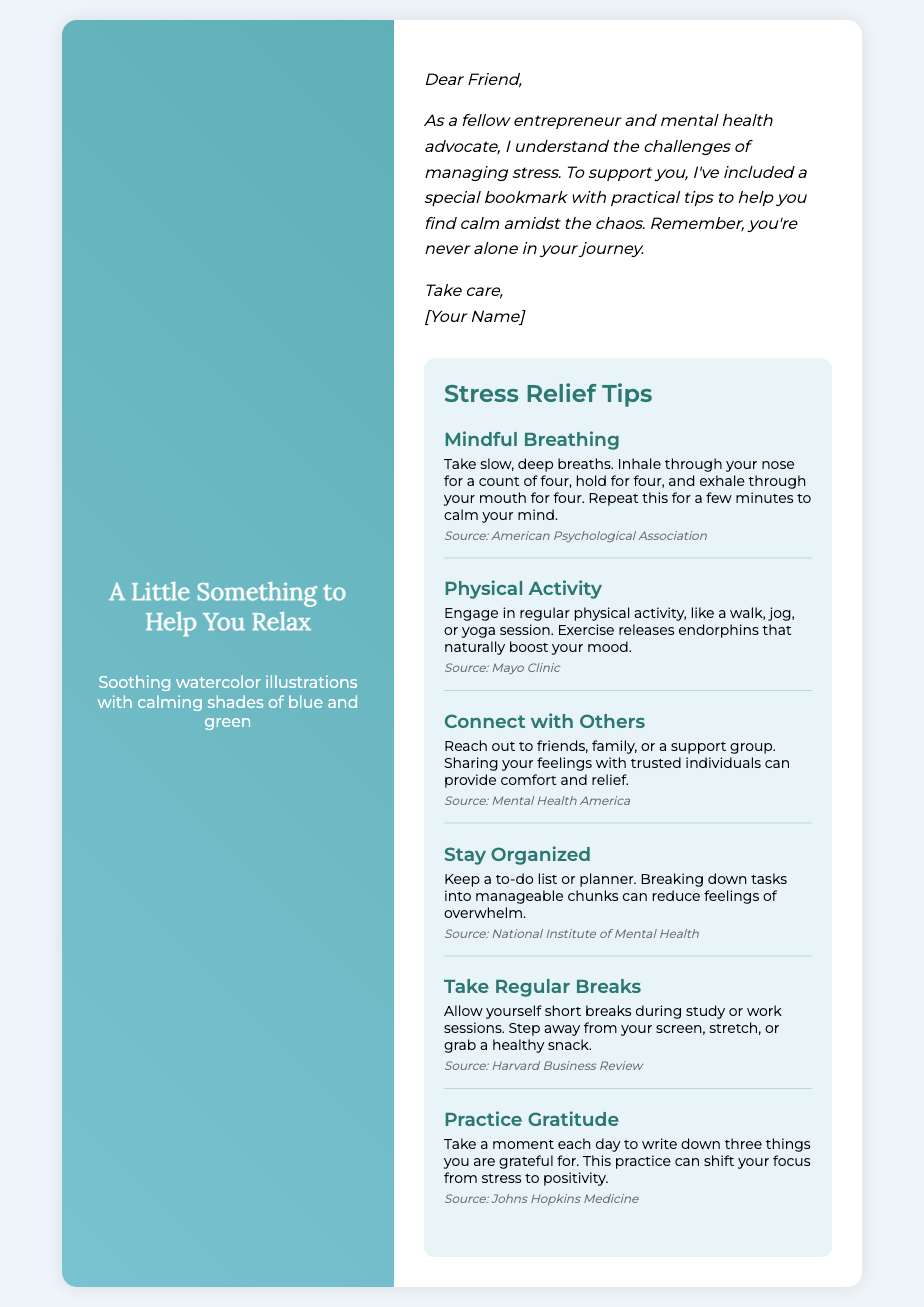What is the title of the card? The title of the card is displayed prominently in the card cover section.
Answer: A Little Something to Help You Relax How many stress relief tips are provided? The number of tips can be counted from the list in the bookmark section.
Answer: Six What is the first stress relief tip mentioned? The first tip is listed at the top of the tips section.
Answer: Mindful Breathing Which organization is cited as the source for the tip on physical activity? The source can be found at the end of the physical activity tip description.
Answer: Mayo Clinic What color palette is used for the card's design? The color scheme is described in the card cover section.
Answer: Calming shades of blue and green What does the inside message encourage the reader to do? The inside message includes supportive language aimed at the reader.
Answer: Find calm amidst the chaos What is one activity mentioned that helps relieve stress? Activities are outlined in the tips list, and one can be identified.
Answer: Yoga session Who is the card addressed to? The salutation in the inside message identifies the recipient.
Answer: Dear Friend What emotion is primarily addressed in the card? The content of the card revolves around coping with a specific feeling.
Answer: Stress 